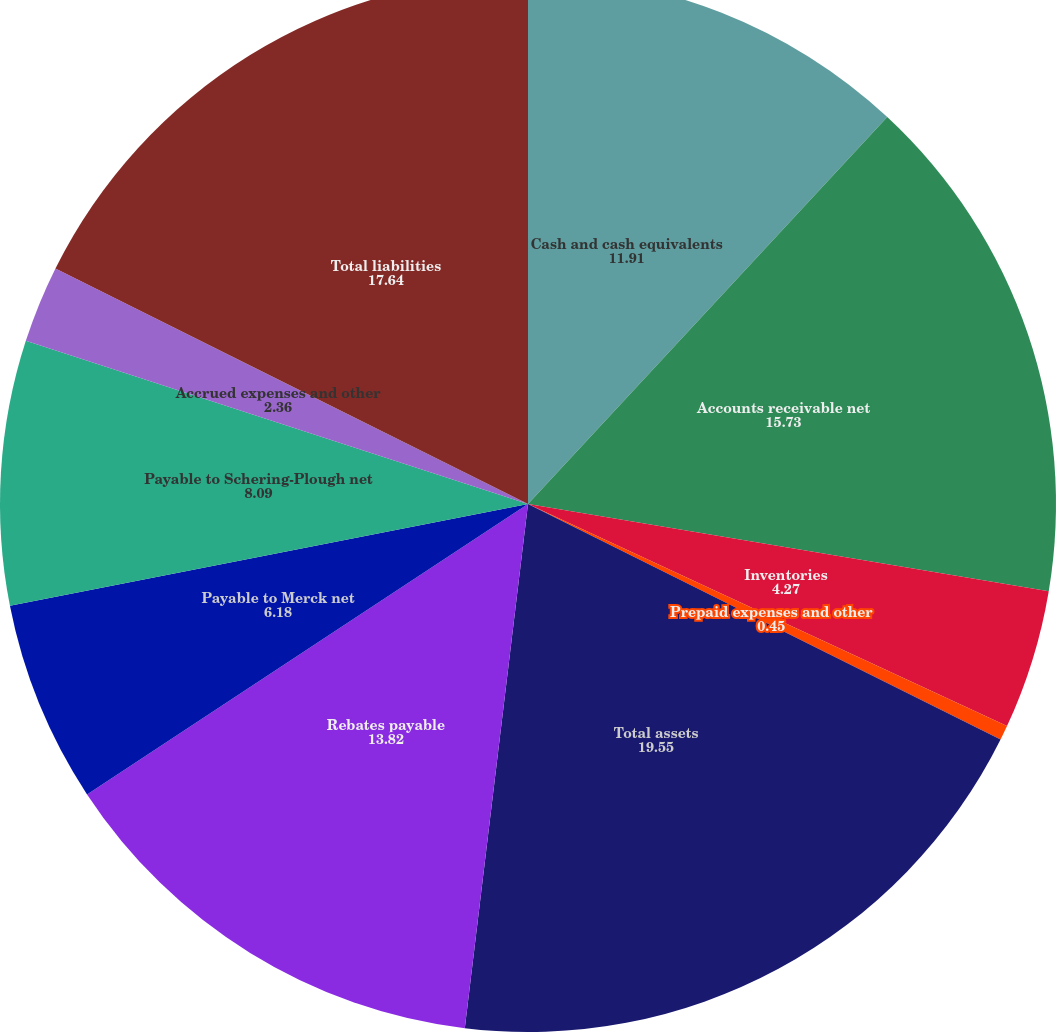<chart> <loc_0><loc_0><loc_500><loc_500><pie_chart><fcel>Cash and cash equivalents<fcel>Accounts receivable net<fcel>Inventories<fcel>Prepaid expenses and other<fcel>Total assets<fcel>Rebates payable<fcel>Payable to Merck net<fcel>Payable to Schering-Plough net<fcel>Accrued expenses and other<fcel>Total liabilities<nl><fcel>11.91%<fcel>15.73%<fcel>4.27%<fcel>0.45%<fcel>19.55%<fcel>13.82%<fcel>6.18%<fcel>8.09%<fcel>2.36%<fcel>17.64%<nl></chart> 